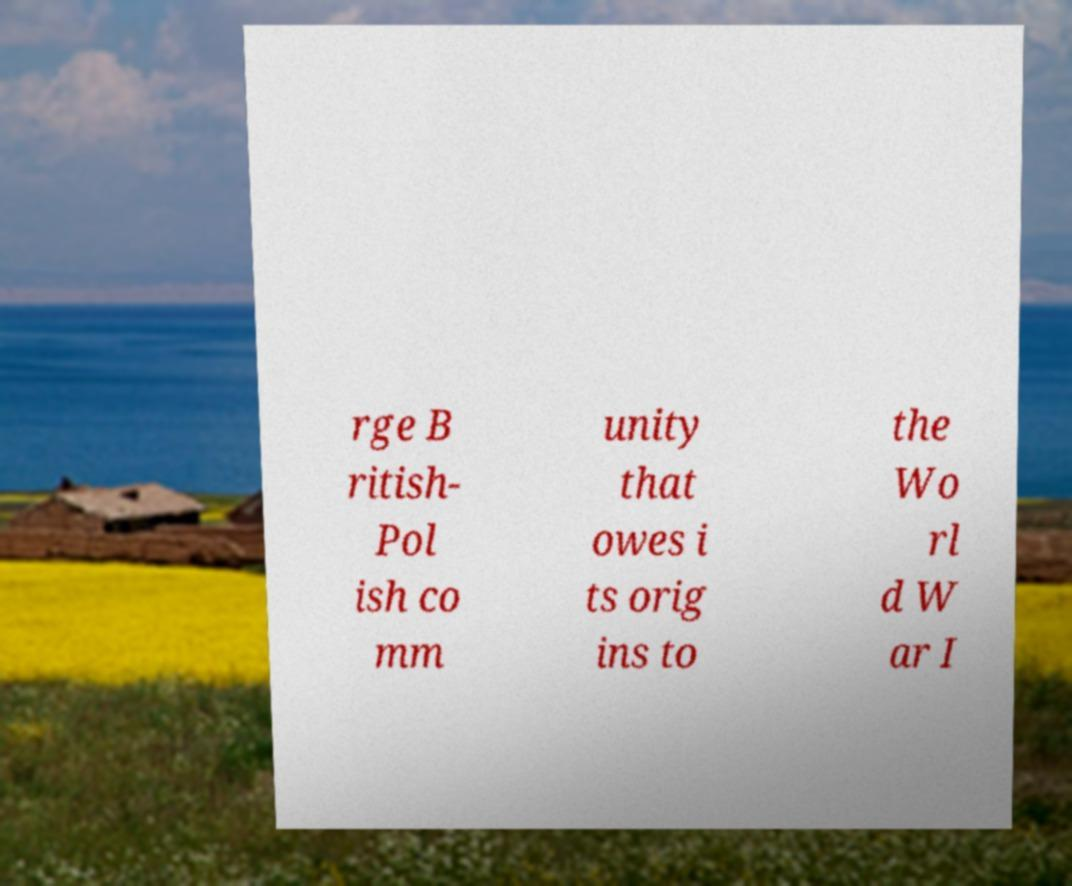For documentation purposes, I need the text within this image transcribed. Could you provide that? rge B ritish- Pol ish co mm unity that owes i ts orig ins to the Wo rl d W ar I 